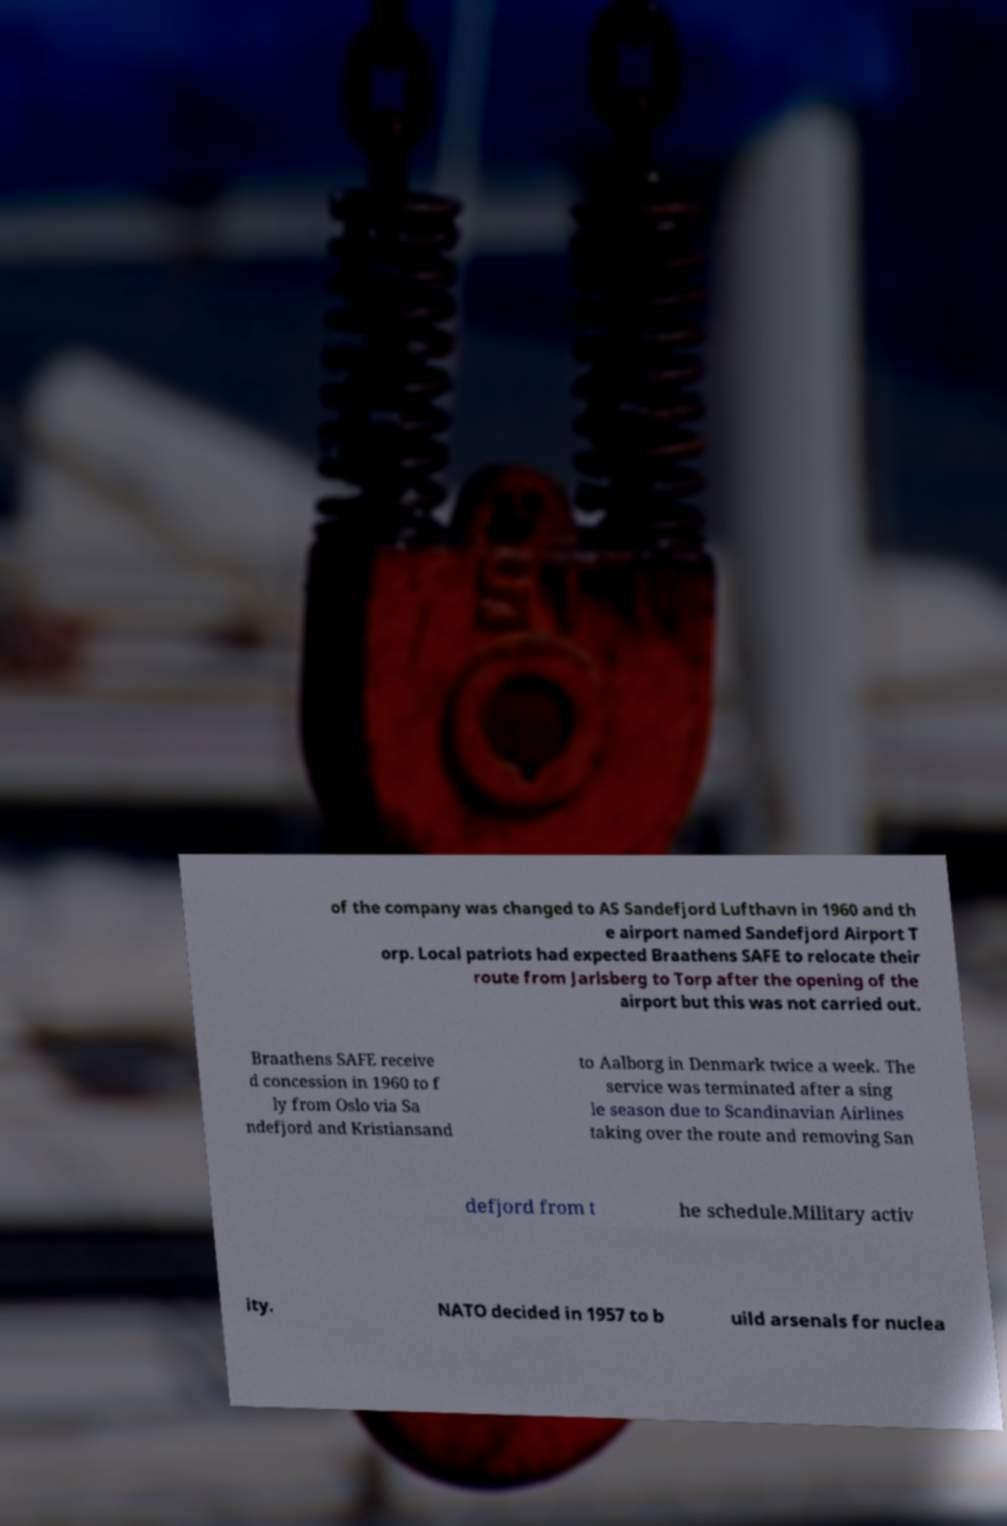Could you assist in decoding the text presented in this image and type it out clearly? of the company was changed to AS Sandefjord Lufthavn in 1960 and th e airport named Sandefjord Airport T orp. Local patriots had expected Braathens SAFE to relocate their route from Jarlsberg to Torp after the opening of the airport but this was not carried out. Braathens SAFE receive d concession in 1960 to f ly from Oslo via Sa ndefjord and Kristiansand to Aalborg in Denmark twice a week. The service was terminated after a sing le season due to Scandinavian Airlines taking over the route and removing San defjord from t he schedule.Military activ ity. NATO decided in 1957 to b uild arsenals for nuclea 